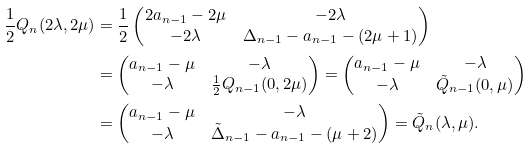Convert formula to latex. <formula><loc_0><loc_0><loc_500><loc_500>\frac { 1 } { 2 } Q _ { n } ( 2 \lambda , 2 \mu ) & = \frac { 1 } { 2 } \begin{pmatrix} 2 a _ { n - 1 } - 2 \mu & - 2 \lambda \\ - 2 \lambda & \Delta _ { n - 1 } - a _ { n - 1 } - ( 2 \mu + 1 ) \end{pmatrix} \\ & = \begin{pmatrix} a _ { n - 1 } - \mu & - \lambda \\ - \lambda & \frac { 1 } { 2 } Q _ { n - 1 } ( 0 , 2 \mu ) \end{pmatrix} = \begin{pmatrix} a _ { n - 1 } - \mu & - \lambda \\ - \lambda & \tilde { Q } _ { n - 1 } ( 0 , \mu ) \end{pmatrix} \\ & = \begin{pmatrix} a _ { n - 1 } - \mu & - \lambda \\ - \lambda & \tilde { \Delta } _ { n - 1 } - a _ { n - 1 } - ( \mu + 2 ) \end{pmatrix} = \tilde { Q } _ { n } ( \lambda , \mu ) .</formula> 